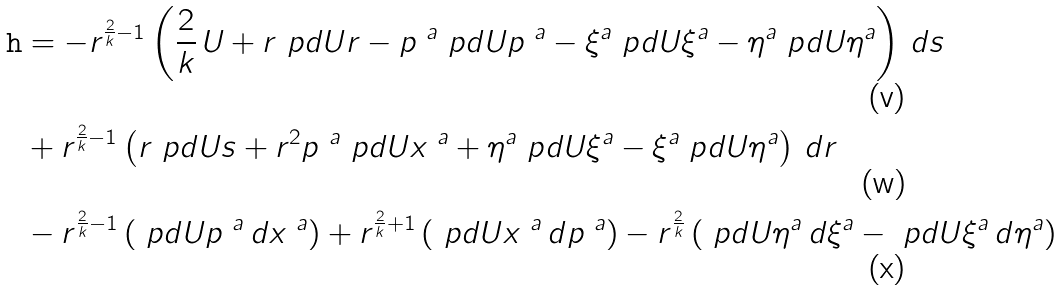Convert formula to latex. <formula><loc_0><loc_0><loc_500><loc_500>\tt h & = - r ^ { \frac { 2 } { k } - 1 } \left ( \frac { 2 } { k } \, U + r \ p d { U } { r } - p ^ { \ a } \ p d { U } { p ^ { \ a } } - \xi ^ { a } \ p d { U } { \xi ^ { a } } - \eta ^ { a } \ p d { U } { \eta ^ { a } } \right ) \, d s \\ & + r ^ { \frac { 2 } { k } - 1 } \left ( r \ p d { U } { s } + r ^ { 2 } p ^ { \ a } \ p d { U } { x ^ { \ a } } + \eta ^ { a } \ p d { U } { \xi ^ { a } } - \xi ^ { a } \ p d { U } { \eta ^ { a } } \right ) \, d r \\ & - r ^ { \frac { 2 } { k } - 1 } \left ( \ p d { U } { p ^ { \ a } } \, d x ^ { \ a } \right ) + r ^ { \frac { 2 } { k } + 1 } \left ( \ p d { U } { x ^ { \ a } } \, d p ^ { \ a } \right ) - r ^ { \frac { 2 } { k } } \left ( \ p d { U } { \eta ^ { a } } \, d \xi ^ { a } - \ p d { U } { \xi ^ { a } } \, d \eta ^ { a } \right )</formula> 